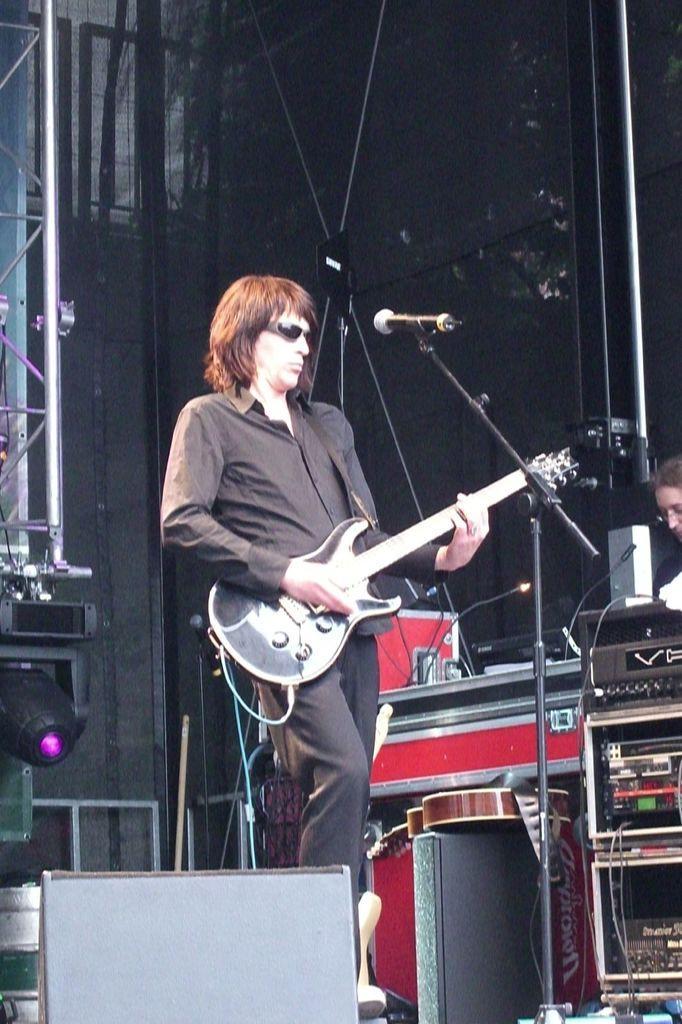In one or two sentences, can you explain what this image depicts? In this image I can see the person is standing and holding the guitar. In front I can see the mic, stand and few objects. I can see few musical instruments, light and black color background. 